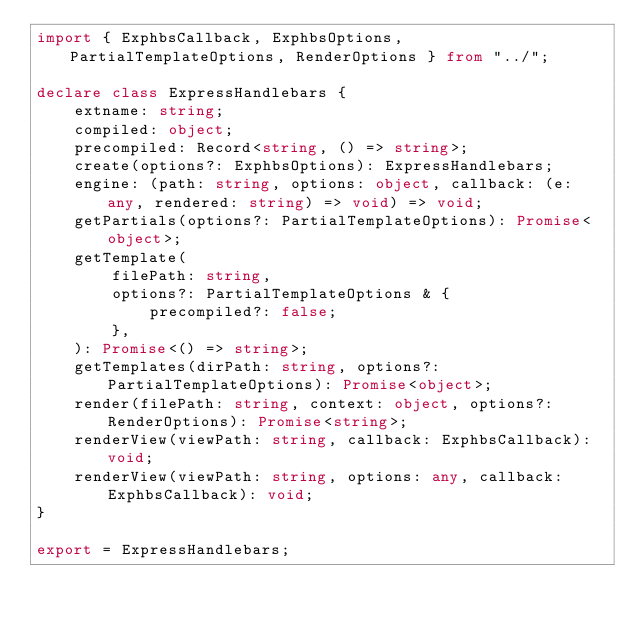<code> <loc_0><loc_0><loc_500><loc_500><_TypeScript_>import { ExphbsCallback, ExphbsOptions, PartialTemplateOptions, RenderOptions } from "../";

declare class ExpressHandlebars {
    extname: string;
    compiled: object;
    precompiled: Record<string, () => string>;
    create(options?: ExphbsOptions): ExpressHandlebars;
    engine: (path: string, options: object, callback: (e: any, rendered: string) => void) => void;
    getPartials(options?: PartialTemplateOptions): Promise<object>;
    getTemplate(
        filePath: string,
        options?: PartialTemplateOptions & {
            precompiled?: false;
        },
    ): Promise<() => string>;
    getTemplates(dirPath: string, options?: PartialTemplateOptions): Promise<object>;
    render(filePath: string, context: object, options?: RenderOptions): Promise<string>;
    renderView(viewPath: string, callback: ExphbsCallback): void;
    renderView(viewPath: string, options: any, callback: ExphbsCallback): void;
}

export = ExpressHandlebars;
</code> 